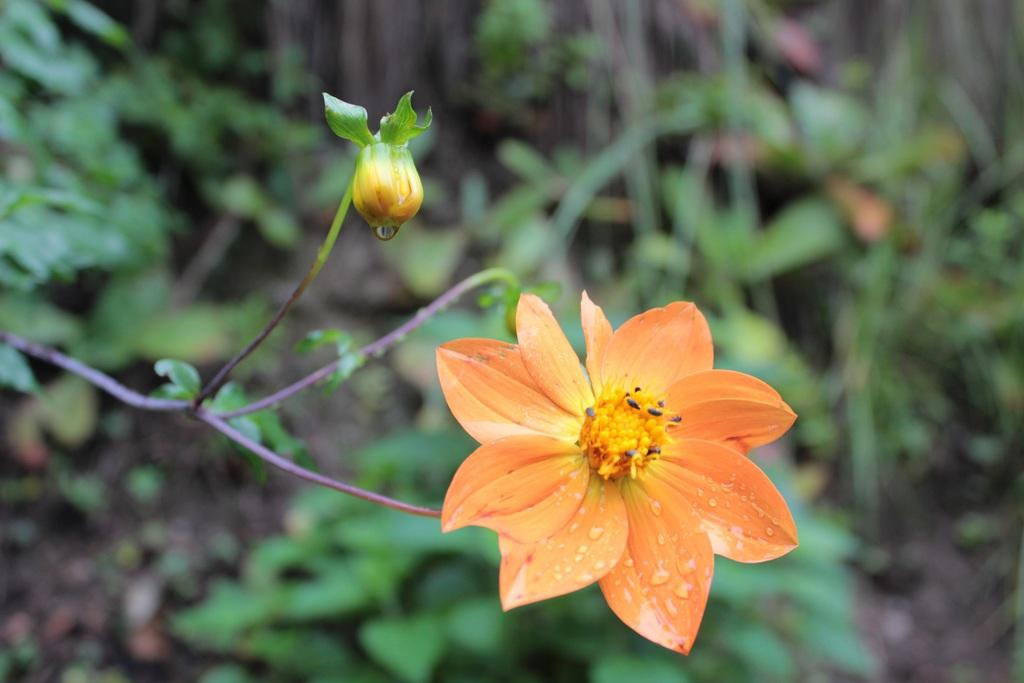What type of plant is located on the left side of the image? There is a flower plant on the left side of the image. What else can be seen in the background of the image? There are other plants in the background of the image. Can you describe the stage of growth of the plant on the left side of the image? There is a bud on the left side of the image. What industry is depicted in the image? There is no industry present in the image; it features plants and flowers. How does the plant on the left side of the image say good-bye to the other plants in the image? Plants do not have the ability to say good-bye, as they are not sentient beings. 